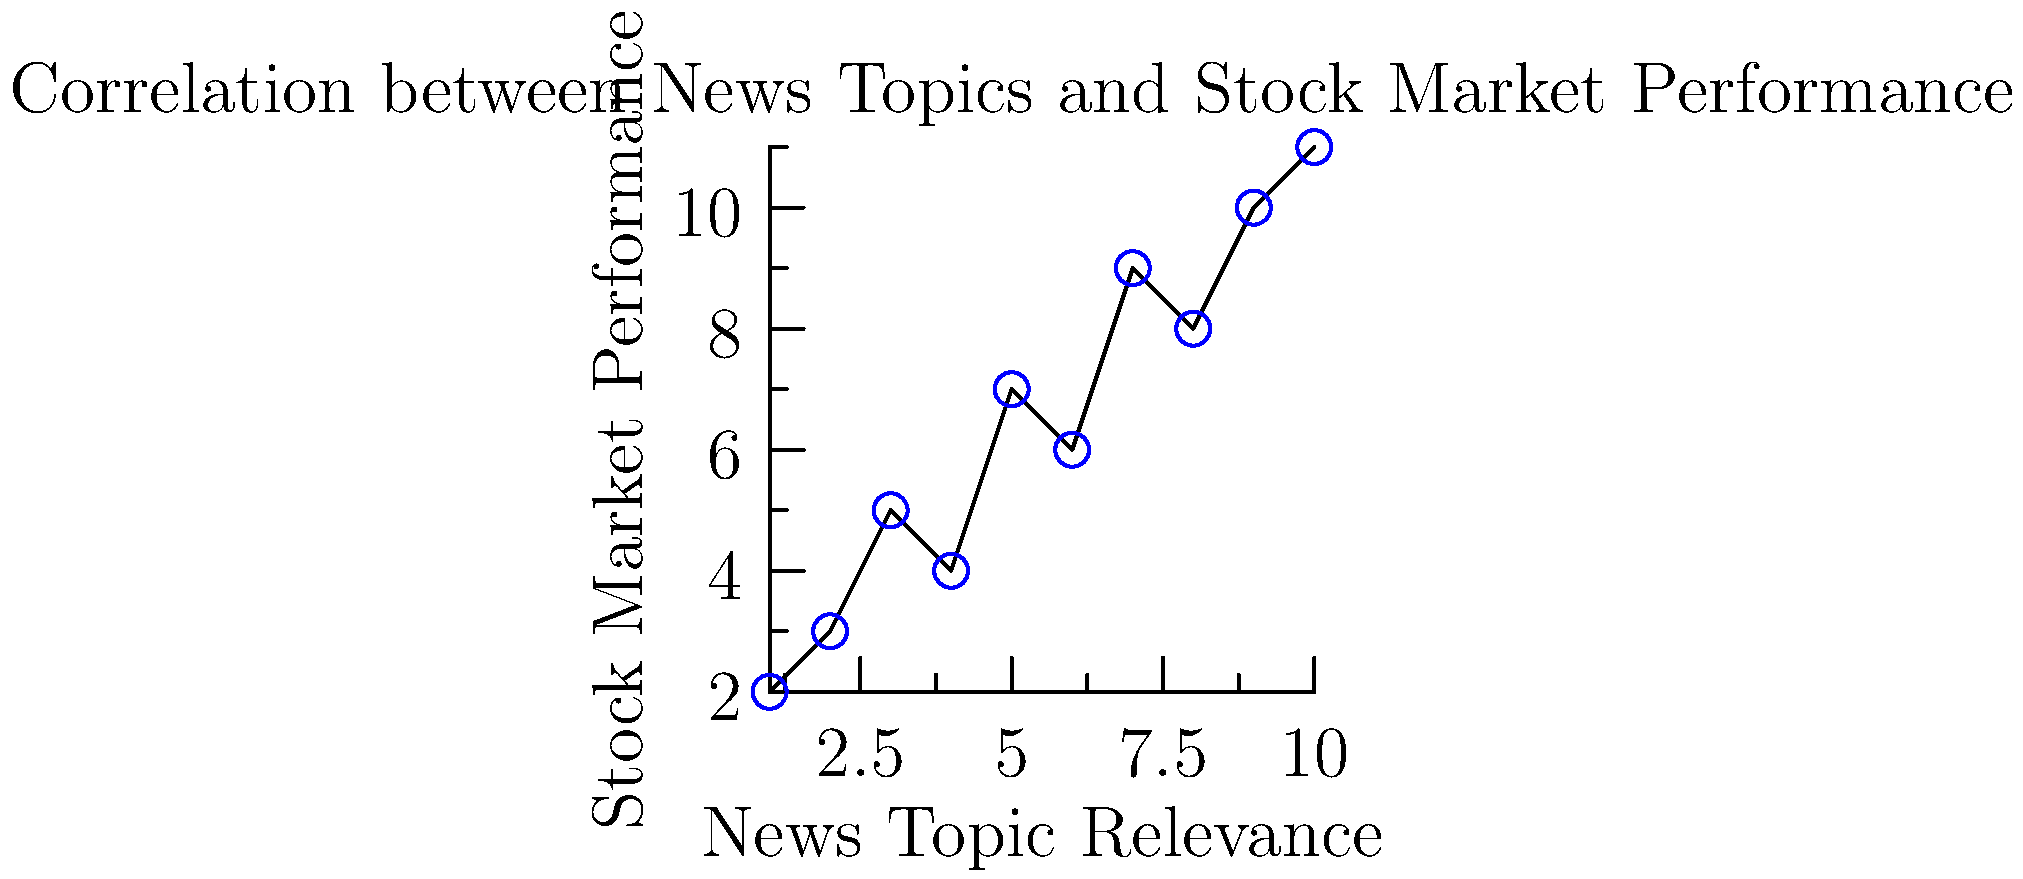Based on the scatter plot showing the correlation between news topic relevance and stock market performance, what type of relationship is observed, and what does this imply for a news aggregator focused on providing summaries for managers? To analyze the relationship between news topic relevance and stock market performance:

1. Observe the general trend of the data points:
   The points show an upward trend from left to right.

2. Identify the correlation type:
   As news topic relevance increases, stock market performance tends to increase.
   This indicates a positive correlation.

3. Assess the strength of the correlation:
   The points roughly follow a linear pattern, but with some scatter.
   This suggests a moderate to strong positive correlation.

4. Interpret the implications:
   a) More relevant news topics are associated with higher stock market performance.
   b) This relationship is not perfect, as there is some scatter in the data.

5. Consider the news aggregator's perspective:
   a) Focusing on highly relevant news topics may provide more value to managers.
   b) The correlation suggests that summarizing important news could help managers 
      anticipate potential stock market movements.
   c) However, other factors also influence stock market performance, so the news 
      aggregator should not claim a causal relationship.

6. Recommendations for the news aggregator:
   a) Prioritize highly relevant news topics in summaries.
   b) Include a diverse range of topics to account for the imperfect correlation.
   c) Provide context about the potential relationship between news and market performance.
Answer: Moderate to strong positive correlation; prioritize relevant topics while maintaining diversity in news summaries. 